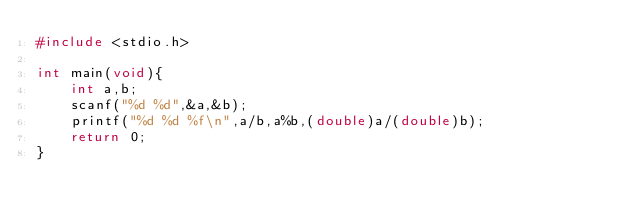Convert code to text. <code><loc_0><loc_0><loc_500><loc_500><_C_>#include <stdio.h>

int main(void){
    int a,b;
    scanf("%d %d",&a,&b);
    printf("%d %d %f\n",a/b,a%b,(double)a/(double)b);
    return 0;
}</code> 